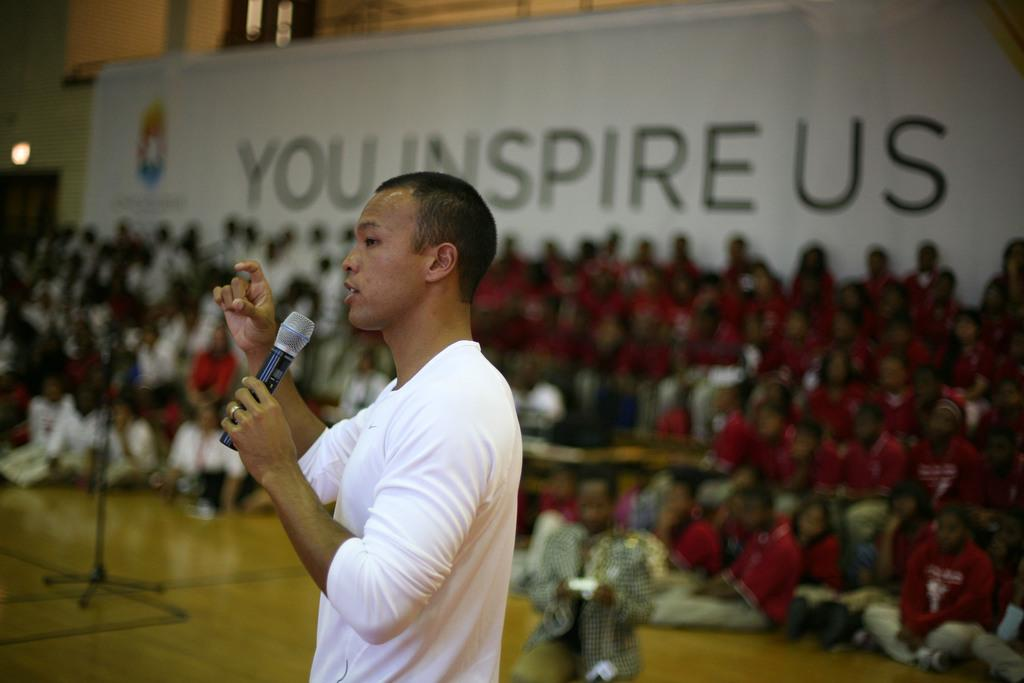What is the person in the image wearing? The person is wearing a white dress in the image. What is the person holding in the image? The person is holding a microphone. What can be seen in the background of the image? There are people and a wall visible in the background of the image. What is the whiteboard used for in the image? The whiteboard is likely used for writing or displaying information. What time of day is it in the alley depicted in the image? There is no alley present in the image; it features a person holding a microphone and a background with people, a wall, and a whiteboard. 